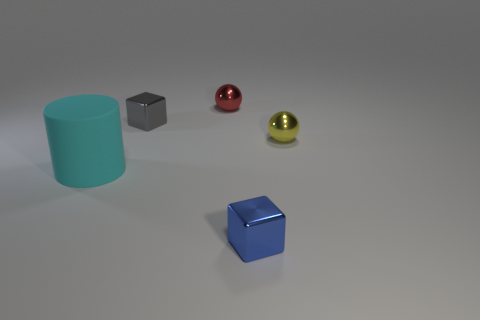What number of tiny things are there?
Provide a succinct answer. 4. Is the shape of the shiny thing that is behind the tiny gray cube the same as  the tiny yellow metallic object?
Your answer should be very brief. Yes. What material is the gray block that is the same size as the blue metallic object?
Keep it short and to the point. Metal. Is there a big thing made of the same material as the tiny gray object?
Your answer should be compact. No. Is the shape of the small red object the same as the shiny object in front of the yellow object?
Your answer should be compact. No. What number of things are both right of the tiny gray cube and behind the large cyan matte thing?
Ensure brevity in your answer.  2. Does the cylinder have the same material as the tiny ball right of the small red thing?
Your response must be concise. No. Are there the same number of big cyan rubber objects that are behind the yellow metallic ball and large blue shiny spheres?
Your response must be concise. Yes. What color is the shiny thing that is in front of the matte cylinder?
Your answer should be very brief. Blue. What number of other objects are the same color as the cylinder?
Ensure brevity in your answer.  0. 